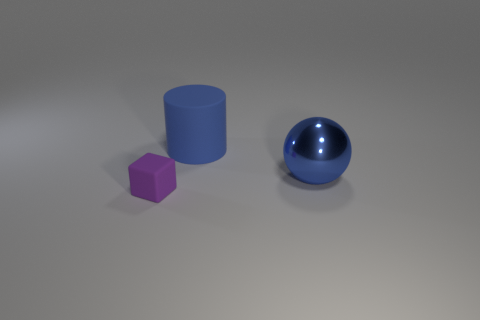What shape is the matte object that is the same size as the metallic object?
Keep it short and to the point. Cylinder. There is a rubber thing to the right of the purple cube; what is its shape?
Make the answer very short. Cylinder. Are there fewer metal spheres that are to the right of the big blue metal sphere than large balls on the left side of the large blue matte object?
Your answer should be very brief. No. Does the purple object have the same size as the blue object that is behind the blue metal ball?
Keep it short and to the point. No. How many objects are the same size as the rubber cylinder?
Your response must be concise. 1. There is a large object that is the same material as the small purple cube; what color is it?
Provide a succinct answer. Blue. Is the number of cyan objects greater than the number of metallic things?
Keep it short and to the point. No. Is the material of the large blue cylinder the same as the tiny purple object?
Provide a succinct answer. Yes. The small object that is made of the same material as the big cylinder is what shape?
Keep it short and to the point. Cube. Is the number of brown rubber blocks less than the number of small blocks?
Your answer should be very brief. Yes. 